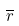Convert formula to latex. <formula><loc_0><loc_0><loc_500><loc_500>\overline { r }</formula> 